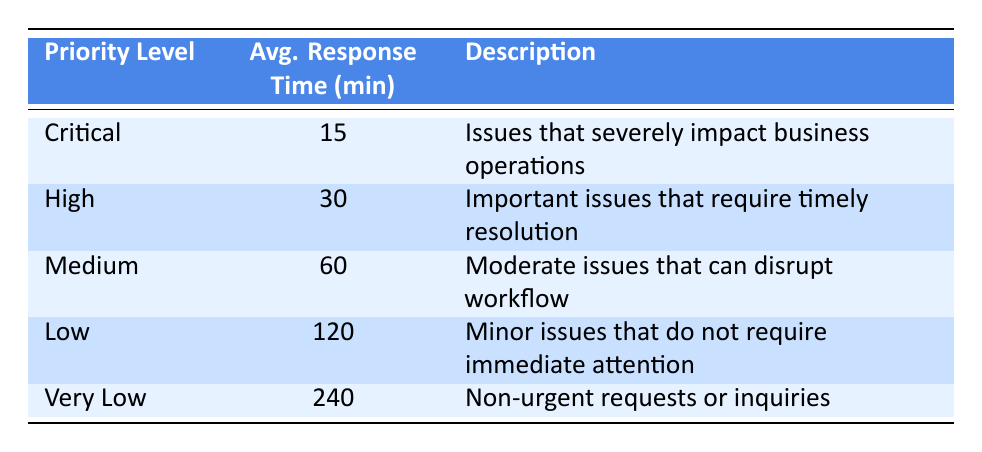What is the average response time for Critical tickets? The table indicates that the average response time for Critical tickets is listed directly under the Avg. Response Time column, showing a value of 15 minutes.
Answer: 15 minutes How many minutes on average does it take to respond to High priority tickets? Referring to the table, the average response time specified for High priority tickets is found in the second row, which states 30 minutes.
Answer: 30 minutes Is the average response time for Low priority tickets greater than that for Medium priority tickets? By examining the table, Low priority tickets have an average response time of 120 minutes, while Medium priority tickets have 60 minutes. Since 120 is greater than 60, the answer is yes.
Answer: Yes What is the total average response time for Critical and High priority tickets combined? From the table, the average response time for Critical tickets is 15 minutes and for High tickets is 30 minutes. The sum of these two values is 15 + 30 = 45 minutes.
Answer: 45 minutes True or False: The average response time for Very Low priority tickets is less than 180 minutes. The table indicates that the average response time for Very Low priority tickets is listed as 240 minutes, so it is not less than 180 minutes. Therefore, the statement is false.
Answer: False Which priority level has the shortest average response time? By reviewing the table, it can be noted that Critical priority tickets have the shortest average response time of 15 minutes compared to the other levels.
Answer: Critical How many priority levels have an average response time of 60 minutes or more? The table lists Medium (60 minutes), Low (120 minutes), and Very Low (240 minutes) priority levels, totaling three levels that meet the criteria.
Answer: Three If you were to rank the priority levels by their average response time from shortest to longest, which would be in the last position? Looking at the average response times in the table, Very Low priority tickets take the longest at 240 minutes, placing it in the last position in the ranking.
Answer: Very Low What is the median average response time of all the priority levels? To find the median, list the average response times in order: 15, 30, 60, 120, 240. The middle value of this sorted list (with five values) is the third one, which is 60 minutes.
Answer: 60 minutes 